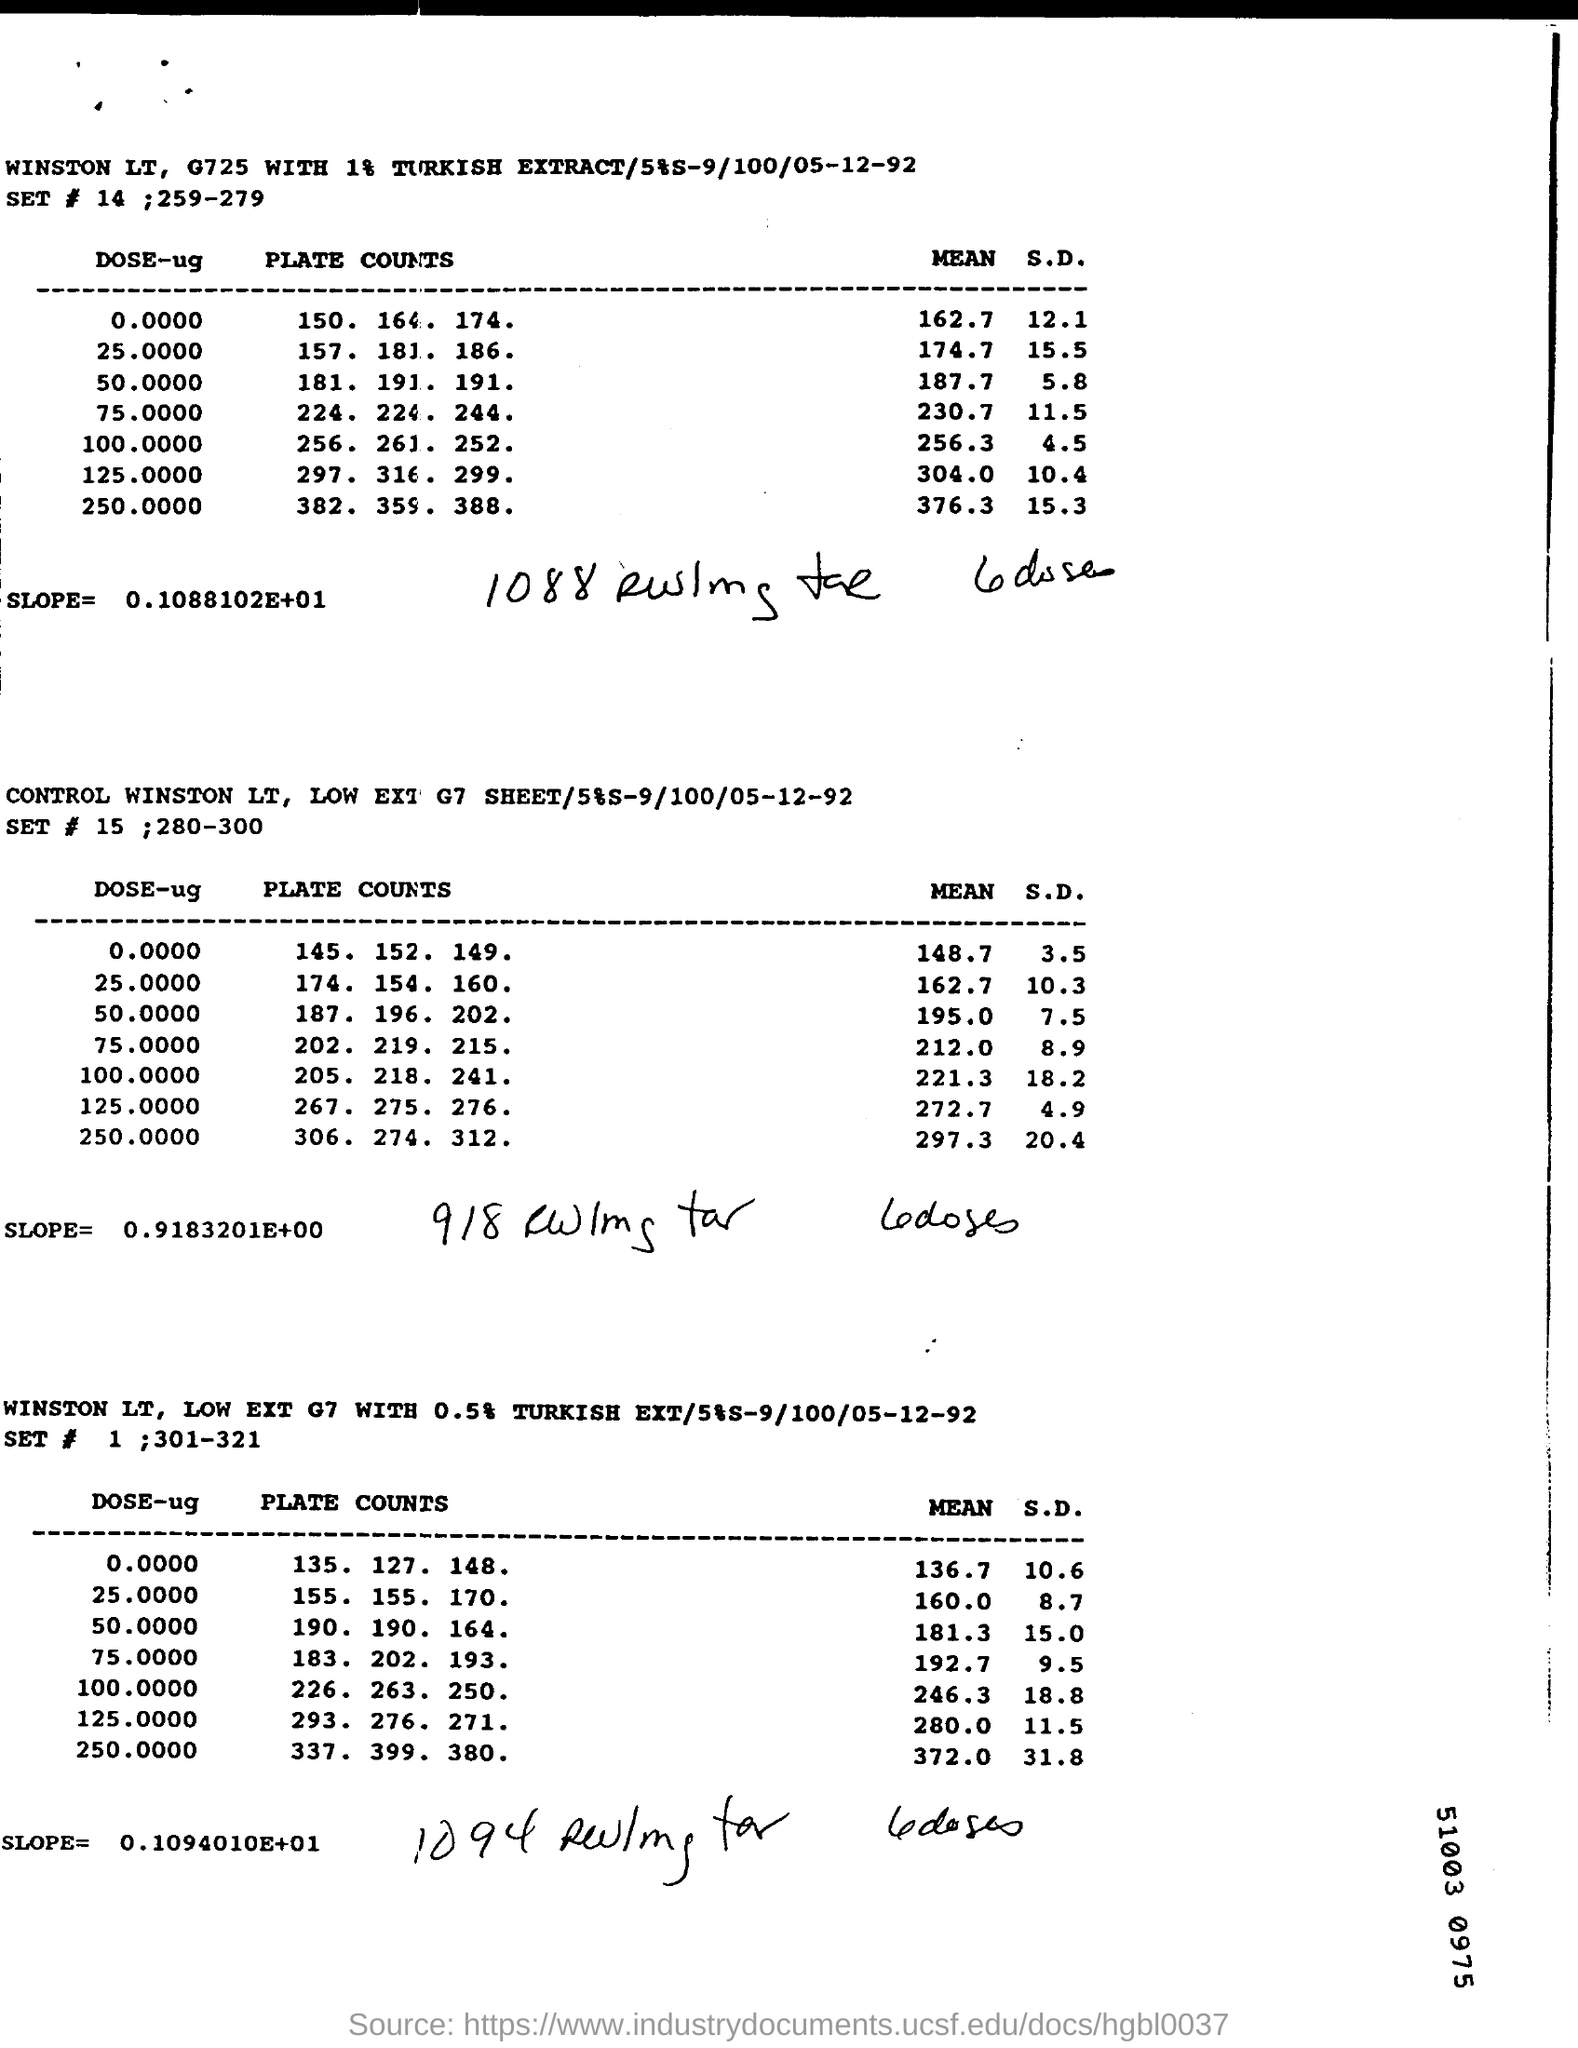Highlight a few significant elements in this photo. The SD (Standard Deviation) mentioned in the DOSE-ug column of the third table is 0.0000 and is equal to 10.6. The date mentioned in the second table is December 5, 1992. The slope mentioned in the first table is 0.1088102. 